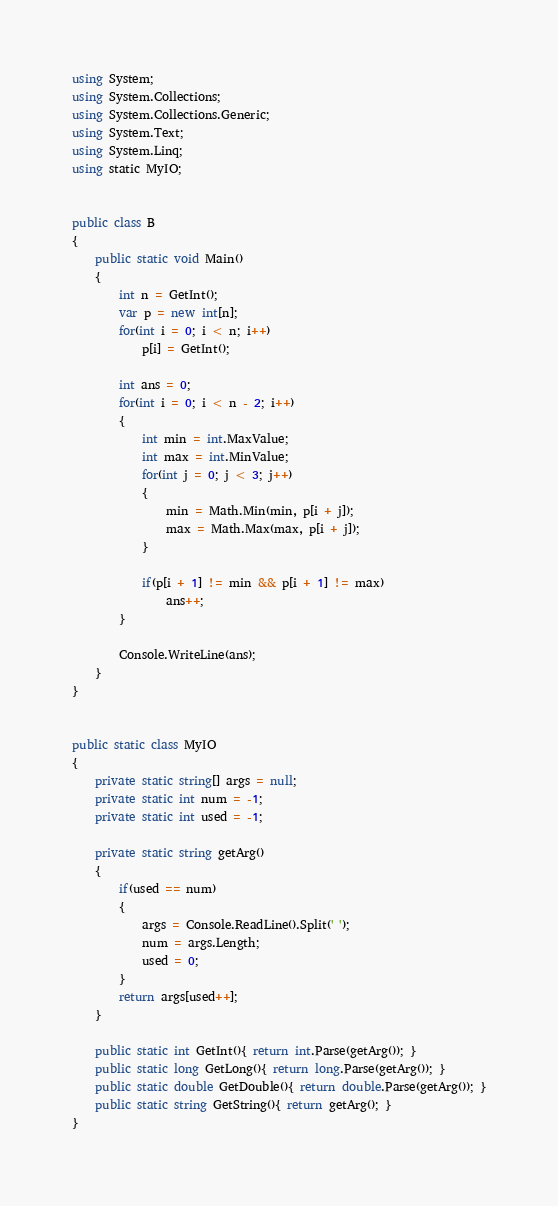Convert code to text. <code><loc_0><loc_0><loc_500><loc_500><_C#_>using System;
using System.Collections;
using System.Collections.Generic;
using System.Text;
using System.Linq;
using static MyIO;


public class B
{
	public static void Main()
	{
		int n = GetInt();
		var p = new int[n];
		for(int i = 0; i < n; i++)
			p[i] = GetInt();

		int ans = 0;
		for(int i = 0; i < n - 2; i++)
		{
			int min = int.MaxValue;
			int max = int.MinValue;
			for(int j = 0; j < 3; j++)
			{
				min = Math.Min(min, p[i + j]);
				max = Math.Max(max, p[i + j]);
			}

			if(p[i + 1] != min && p[i + 1] != max)
				ans++;
		}

		Console.WriteLine(ans);
	}
}


public static class MyIO
{
	private static string[] args = null;
	private static int num = -1;
	private static int used = -1;

	private static string getArg()
	{
		if(used == num)
		{
			args = Console.ReadLine().Split(' ');
			num = args.Length;
			used = 0;
		}
		return args[used++];
	}

	public static int GetInt(){ return int.Parse(getArg()); }
	public static long GetLong(){ return long.Parse(getArg()); }
	public static double GetDouble(){ return double.Parse(getArg()); }
	public static string GetString(){ return getArg(); }
}
</code> 